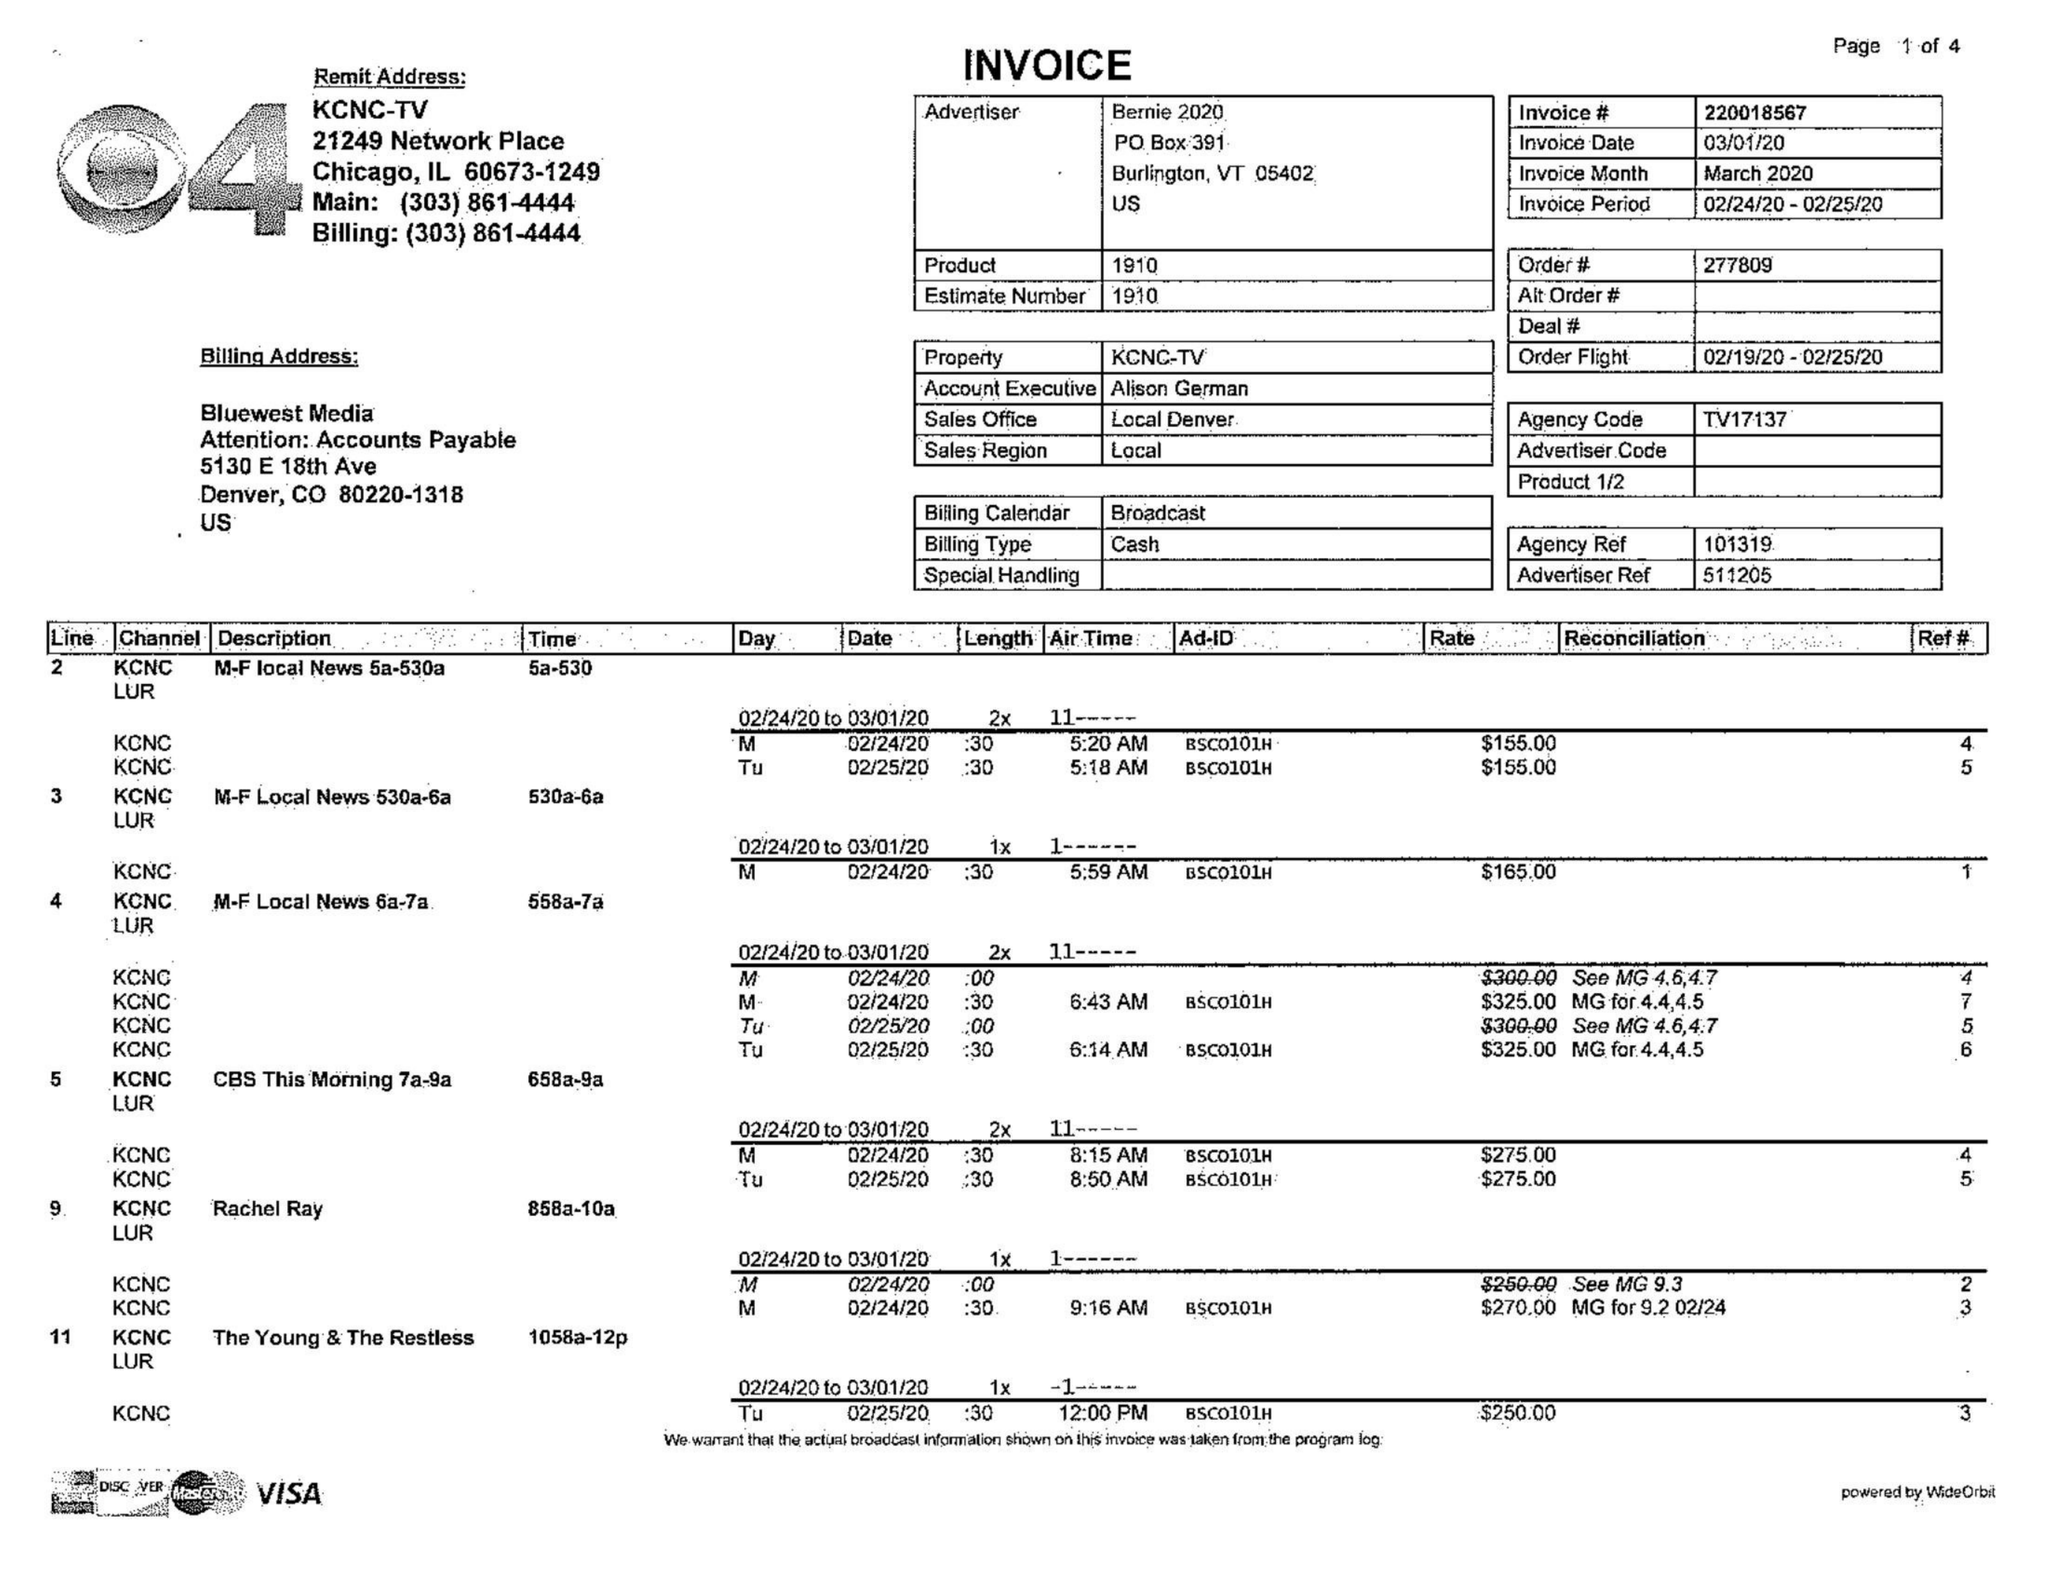What is the value for the contract_num?
Answer the question using a single word or phrase. 220018567 